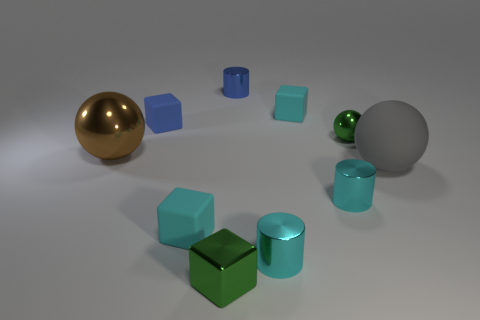What is the shape of the tiny blue thing that is to the right of the green metallic cube?
Offer a very short reply. Cylinder. What is the color of the small metallic cylinder behind the metal ball that is behind the large brown sphere that is in front of the blue matte object?
Ensure brevity in your answer.  Blue. What shape is the green object that is the same material as the tiny green block?
Your answer should be compact. Sphere. Is the number of blue rubber cubes less than the number of large purple metallic cylinders?
Provide a succinct answer. No. Is the material of the tiny ball the same as the gray sphere?
Offer a terse response. No. How many other objects are the same color as the tiny shiny block?
Offer a terse response. 1. Is the number of large gray spheres greater than the number of tiny cyan rubber cubes?
Your answer should be very brief. No. Does the gray object have the same size as the rubber object in front of the large gray thing?
Keep it short and to the point. No. There is a metallic ball that is right of the big metallic thing; what is its color?
Offer a terse response. Green. How many blue things are rubber spheres or shiny balls?
Provide a succinct answer. 0. 